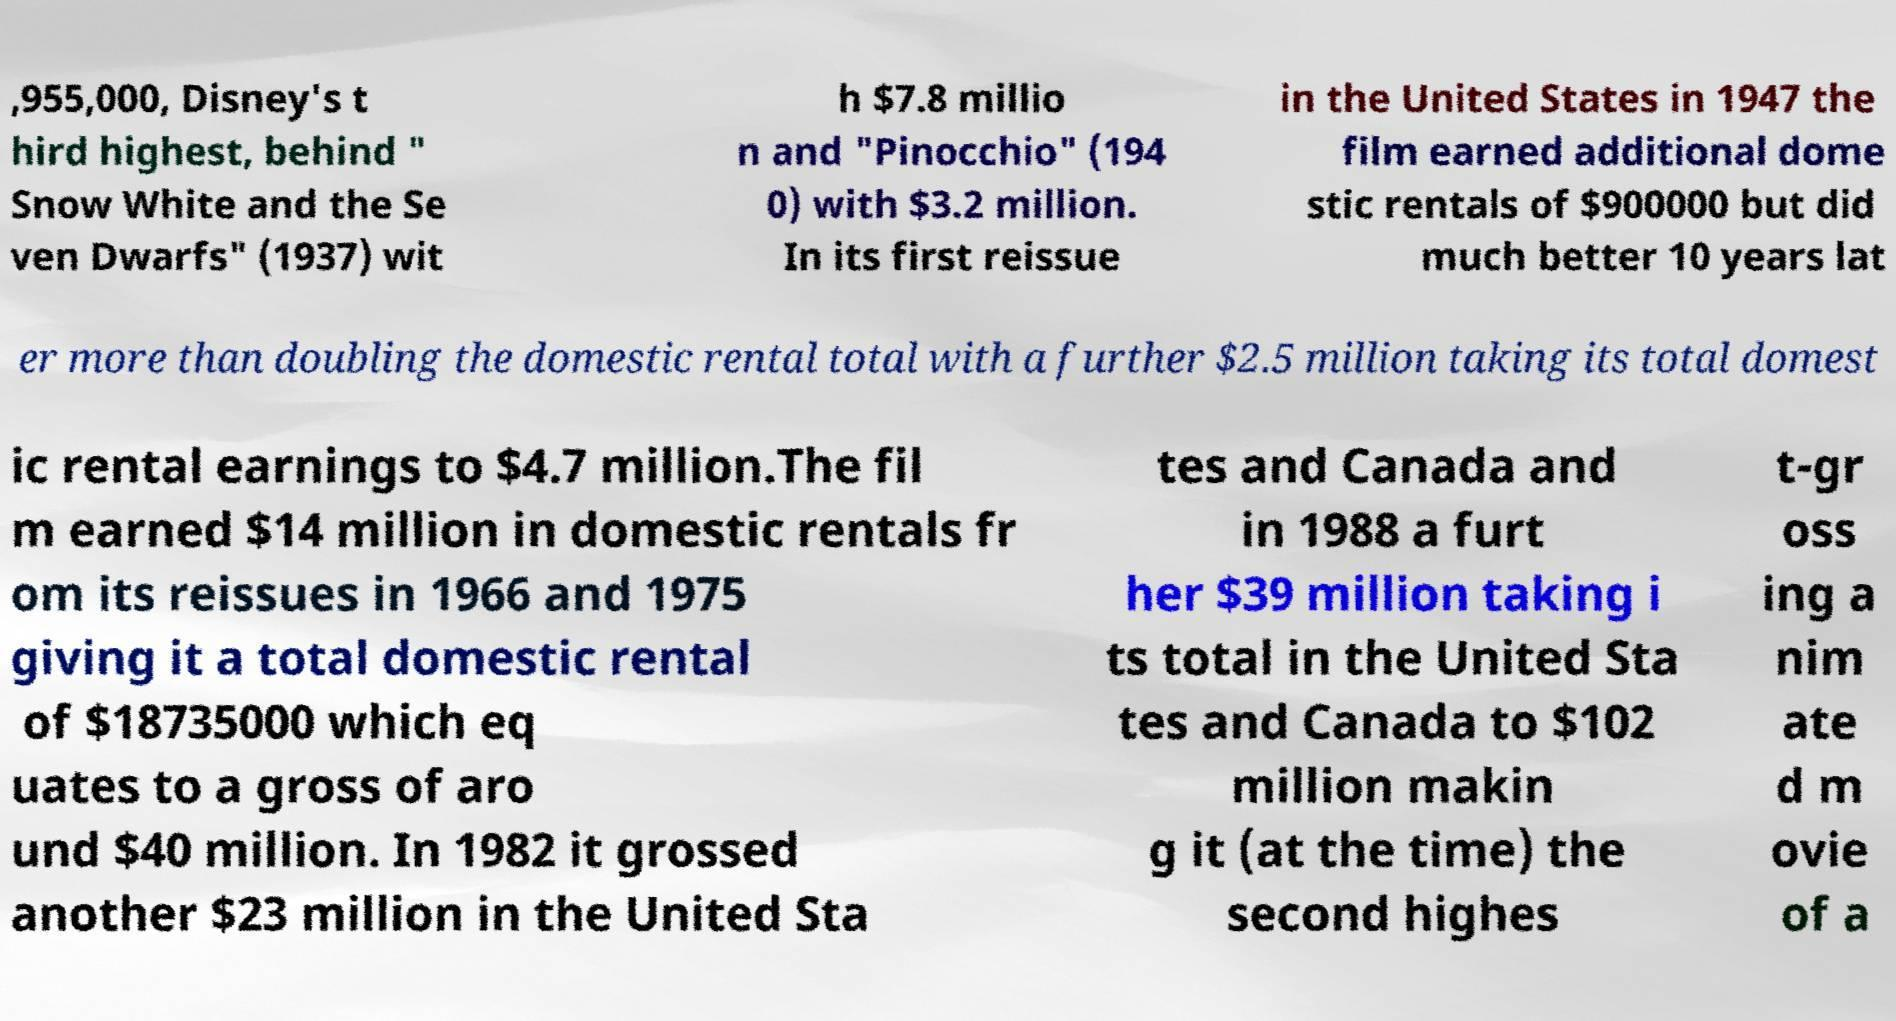Can you read and provide the text displayed in the image?This photo seems to have some interesting text. Can you extract and type it out for me? ,955,000, Disney's t hird highest, behind " Snow White and the Se ven Dwarfs" (1937) wit h $7.8 millio n and "Pinocchio" (194 0) with $3.2 million. In its first reissue in the United States in 1947 the film earned additional dome stic rentals of $900000 but did much better 10 years lat er more than doubling the domestic rental total with a further $2.5 million taking its total domest ic rental earnings to $4.7 million.The fil m earned $14 million in domestic rentals fr om its reissues in 1966 and 1975 giving it a total domestic rental of $18735000 which eq uates to a gross of aro und $40 million. In 1982 it grossed another $23 million in the United Sta tes and Canada and in 1988 a furt her $39 million taking i ts total in the United Sta tes and Canada to $102 million makin g it (at the time) the second highes t-gr oss ing a nim ate d m ovie of a 